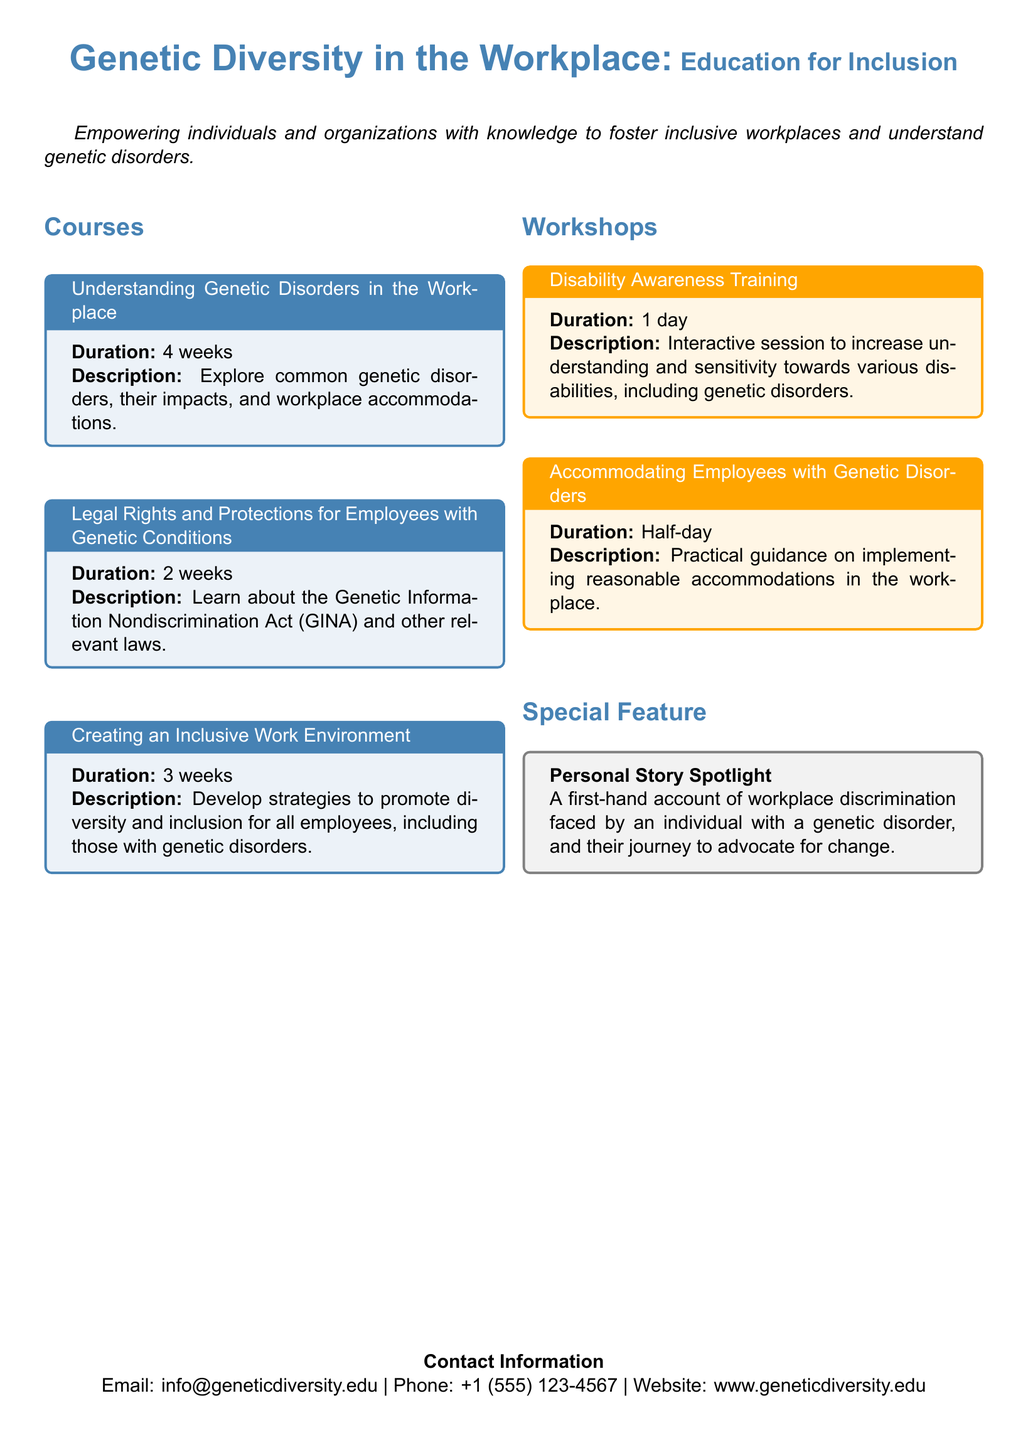What is the title of the catalog? The title of the catalog is prominently displayed at the beginning, stating the focus on genetic diversity and workplace education.
Answer: Genetic Diversity in the Workplace: Education for Inclusion How long does the "Creating an Inclusive Work Environment" course last? The duration of the course can be found under the course title in the document.
Answer: 3 weeks What is the duration of the "Disability Awareness Training" workshop? This information is provided in the description of the workshop section, indicating the length of the training.
Answer: 1 day What is the main objective of the courses and workshops? The introduction outlines the purpose of the program, emphasizing empowerment and inclusivity in the workplace.
Answer: Empowering individuals and organizations with knowledge Which law is covered in the course "Legal Rights and Protections for Employees with Genetic Conditions"? The specific law referenced in the title of the course relates to employee protections concerning genetic information.
Answer: Genetic Information Nondiscrimination Act (GINA) What type of training does the workshop titled "Accommodating Employees with Genetic Disorders" provide? The description specifies what kind of guidance the workshop offers to organizations.
Answer: Practical guidance on implementing reasonable accommodations What additional feature includes personal experiences? The document highlights a specific section dedicated to stories of individuals facing challenges in the workplace.
Answer: Personal Story Spotlight What is the contact email provided in the catalog? The contact information section concludes with an email address for inquiries related to the courses and workshops.
Answer: info@geneticdiversity.edu 